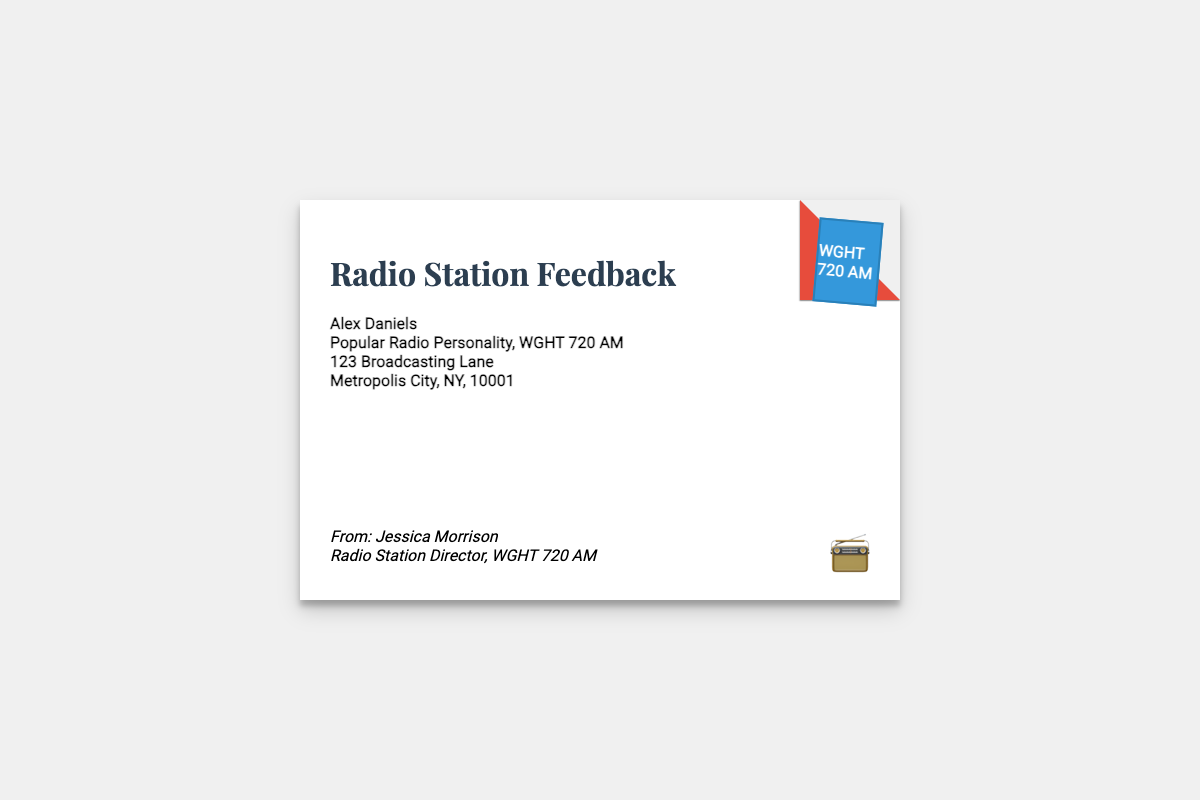What is the name of the radio personality? The document states the name of the radio personality is Alex Daniels.
Answer: Alex Daniels Who sent the feedback? The sender of the feedback is mentioned as Jessica Morrison.
Answer: Jessica Morrison What is the address of the radio personality? The address provided for the radio personality includes 123 Broadcasting Lane, Metropolis City, NY, 10001.
Answer: 123 Broadcasting Lane, Metropolis City, NY, 10001 What is the title of the feedback document? The title of the document is explicitly stated as "Radio Station Feedback".
Answer: Radio Station Feedback What is the stamp's designation? The stamp included in the envelope signifies WGHT 720 AM.
Answer: WGHT 720 AM Who is the recipient of the feedback? The recipient is identified as Alex Daniels, the popular radio personality.
Answer: Alex Daniels What color is the envelope's background? The background color of the envelope is specified as white.
Answer: white What type of document is this? This document can be classified as an envelope, specifically for feedback from the radio station.
Answer: envelope What emoji is used in the document? The emoji represented in the document is a radio icon, displayed as 📻.
Answer: 📻 